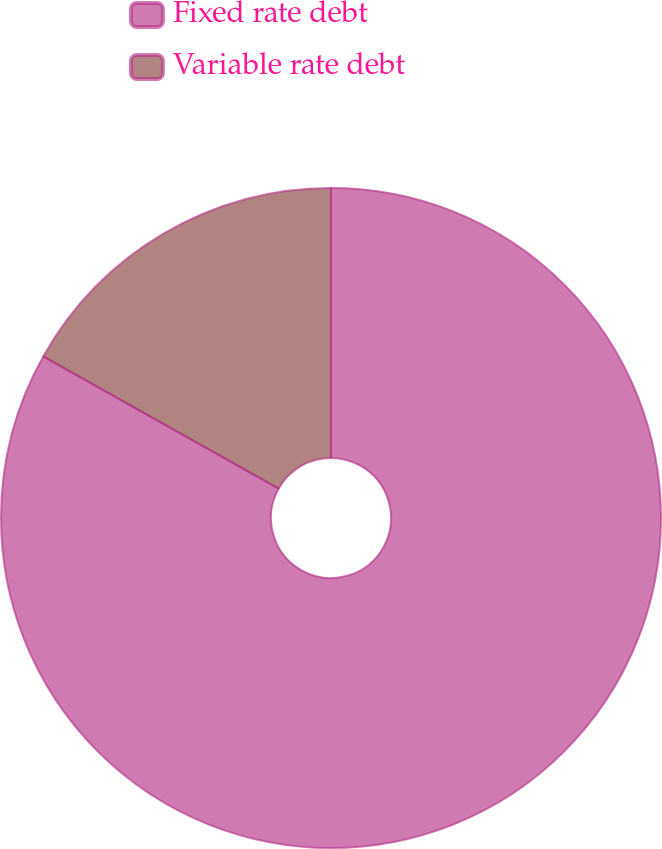Convert chart to OTSL. <chart><loc_0><loc_0><loc_500><loc_500><pie_chart><fcel>Fixed rate debt<fcel>Variable rate debt<nl><fcel>83.14%<fcel>16.86%<nl></chart> 